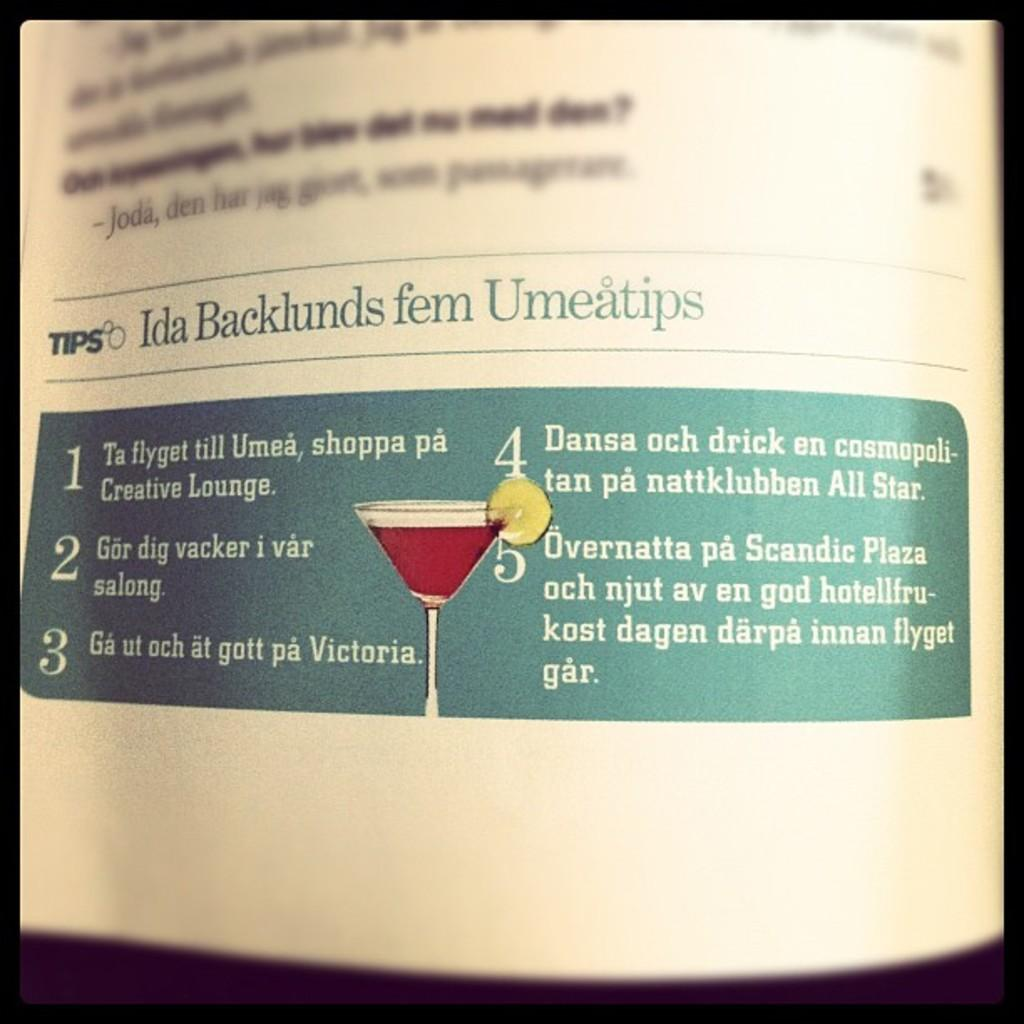<image>
Summarize the visual content of the image. an article reads Ida Backlunds fem Umeatips with a red cocktail 